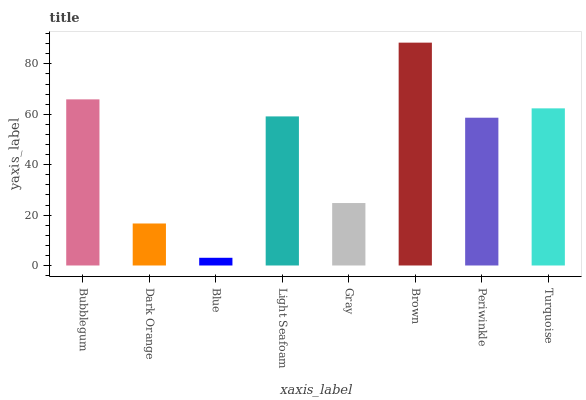Is Blue the minimum?
Answer yes or no. Yes. Is Brown the maximum?
Answer yes or no. Yes. Is Dark Orange the minimum?
Answer yes or no. No. Is Dark Orange the maximum?
Answer yes or no. No. Is Bubblegum greater than Dark Orange?
Answer yes or no. Yes. Is Dark Orange less than Bubblegum?
Answer yes or no. Yes. Is Dark Orange greater than Bubblegum?
Answer yes or no. No. Is Bubblegum less than Dark Orange?
Answer yes or no. No. Is Light Seafoam the high median?
Answer yes or no. Yes. Is Periwinkle the low median?
Answer yes or no. Yes. Is Blue the high median?
Answer yes or no. No. Is Gray the low median?
Answer yes or no. No. 